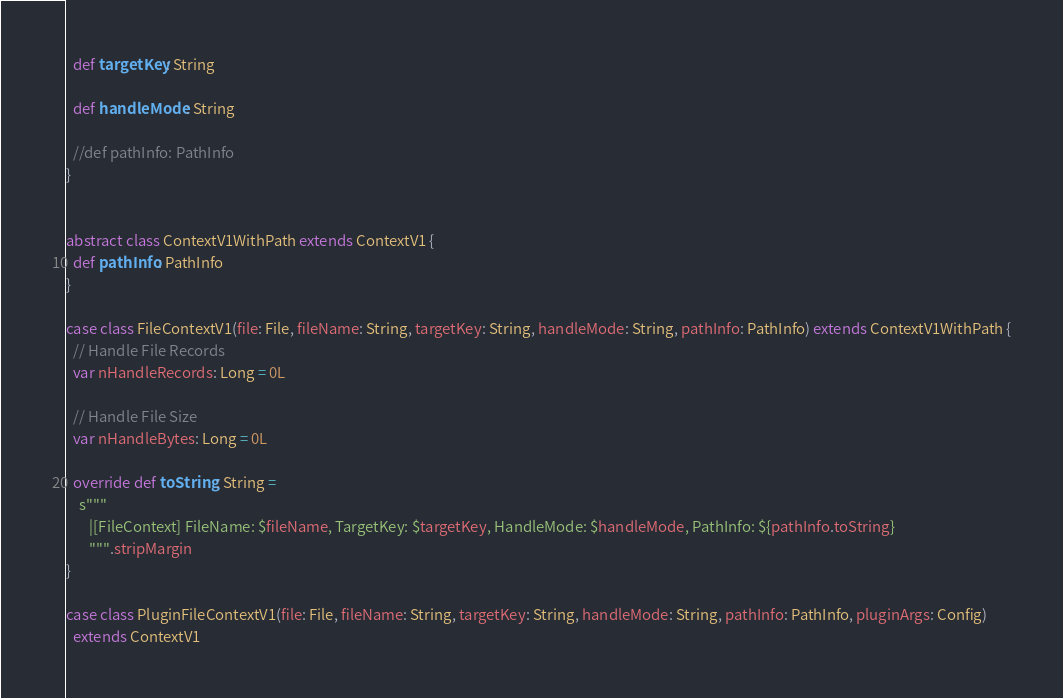<code> <loc_0><loc_0><loc_500><loc_500><_Scala_>  def targetKey: String

  def handleMode: String

  //def pathInfo: PathInfo
}


abstract class ContextV1WithPath extends ContextV1 {
  def pathInfo: PathInfo
}

case class FileContextV1(file: File, fileName: String, targetKey: String, handleMode: String, pathInfo: PathInfo) extends ContextV1WithPath {
  // Handle File Records
  var nHandleRecords: Long = 0L

  // Handle File Size
  var nHandleBytes: Long = 0L

  override def toString: String =
    s"""
       |[FileContext] FileName: $fileName, TargetKey: $targetKey, HandleMode: $handleMode, PathInfo: ${pathInfo.toString}
       """.stripMargin
}

case class PluginFileContextV1(file: File, fileName: String, targetKey: String, handleMode: String, pathInfo: PathInfo, pluginArgs: Config)
  extends ContextV1</code> 